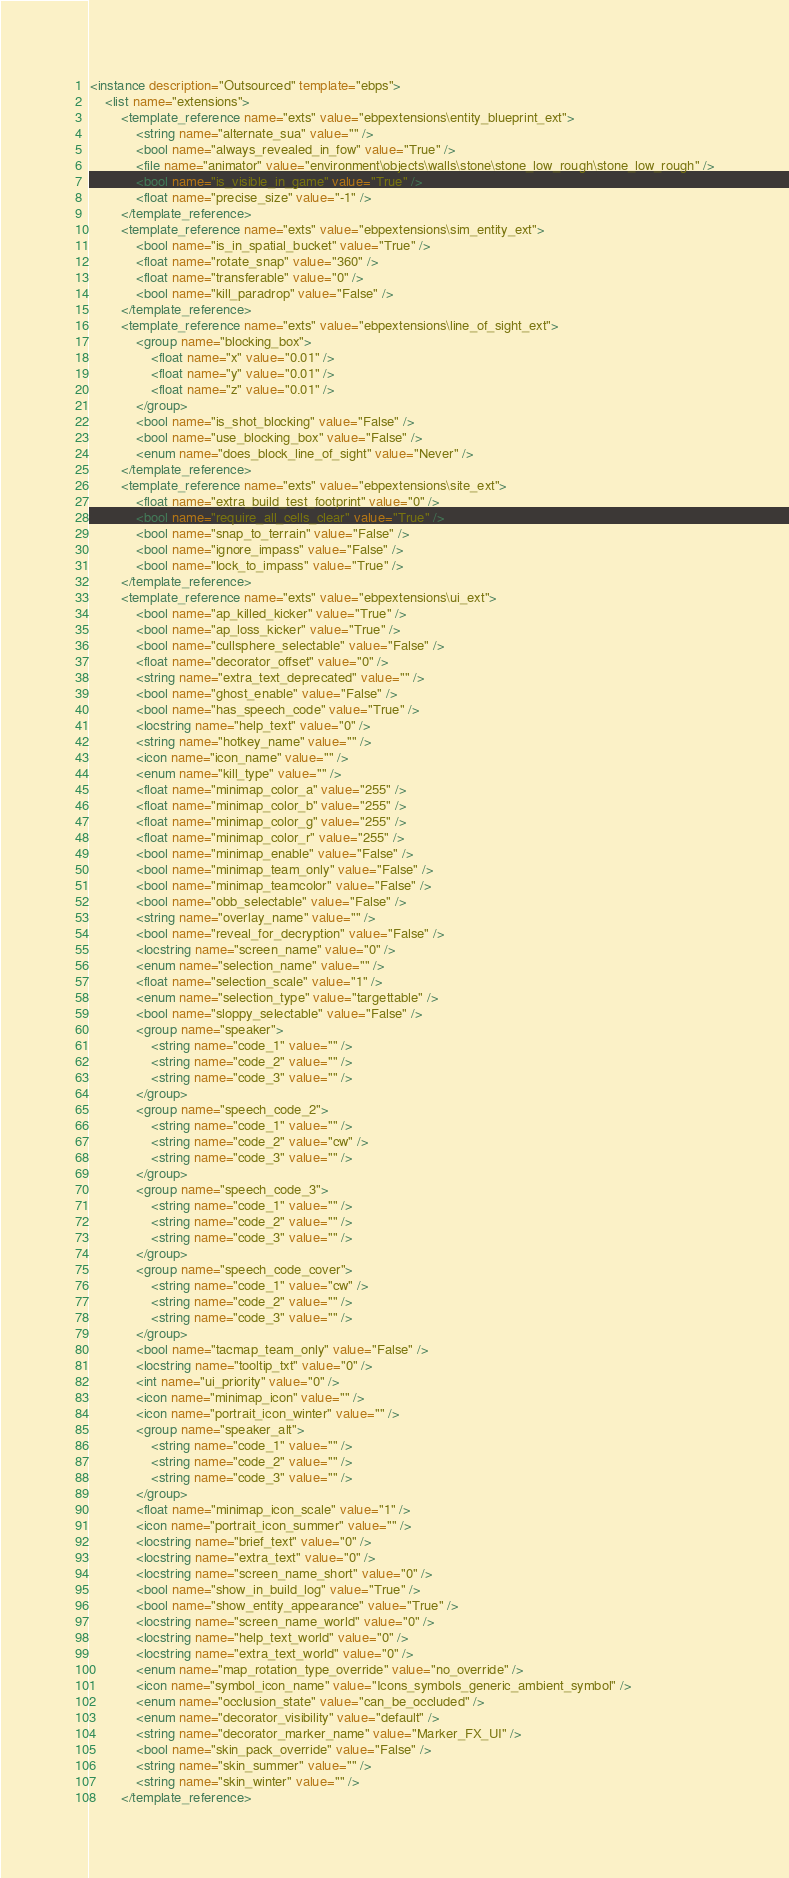Convert code to text. <code><loc_0><loc_0><loc_500><loc_500><_XML_><instance description="Outsourced" template="ebps">
	<list name="extensions">
		<template_reference name="exts" value="ebpextensions\entity_blueprint_ext">
			<string name="alternate_sua" value="" />
			<bool name="always_revealed_in_fow" value="True" />
			<file name="animator" value="environment\objects\walls\stone\stone_low_rough\stone_low_rough" />
			<bool name="is_visible_in_game" value="True" />
			<float name="precise_size" value="-1" />
		</template_reference>
		<template_reference name="exts" value="ebpextensions\sim_entity_ext">
			<bool name="is_in_spatial_bucket" value="True" />
			<float name="rotate_snap" value="360" />
			<float name="transferable" value="0" />
			<bool name="kill_paradrop" value="False" />
		</template_reference>
		<template_reference name="exts" value="ebpextensions\line_of_sight_ext">
			<group name="blocking_box">
				<float name="x" value="0.01" />
				<float name="y" value="0.01" />
				<float name="z" value="0.01" />
			</group>
			<bool name="is_shot_blocking" value="False" />
			<bool name="use_blocking_box" value="False" />
			<enum name="does_block_line_of_sight" value="Never" />
		</template_reference>
		<template_reference name="exts" value="ebpextensions\site_ext">
			<float name="extra_build_test_footprint" value="0" />
			<bool name="require_all_cells_clear" value="True" />
			<bool name="snap_to_terrain" value="False" />
			<bool name="ignore_impass" value="False" />
			<bool name="lock_to_impass" value="True" />
		</template_reference>
		<template_reference name="exts" value="ebpextensions\ui_ext">
			<bool name="ap_killed_kicker" value="True" />
			<bool name="ap_loss_kicker" value="True" />
			<bool name="cullsphere_selectable" value="False" />
			<float name="decorator_offset" value="0" />
			<string name="extra_text_deprecated" value="" />
			<bool name="ghost_enable" value="False" />
			<bool name="has_speech_code" value="True" />
			<locstring name="help_text" value="0" />
			<string name="hotkey_name" value="" />
			<icon name="icon_name" value="" />
			<enum name="kill_type" value="" />
			<float name="minimap_color_a" value="255" />
			<float name="minimap_color_b" value="255" />
			<float name="minimap_color_g" value="255" />
			<float name="minimap_color_r" value="255" />
			<bool name="minimap_enable" value="False" />
			<bool name="minimap_team_only" value="False" />
			<bool name="minimap_teamcolor" value="False" />
			<bool name="obb_selectable" value="False" />
			<string name="overlay_name" value="" />
			<bool name="reveal_for_decryption" value="False" />
			<locstring name="screen_name" value="0" />
			<enum name="selection_name" value="" />
			<float name="selection_scale" value="1" />
			<enum name="selection_type" value="targettable" />
			<bool name="sloppy_selectable" value="False" />
			<group name="speaker">
				<string name="code_1" value="" />
				<string name="code_2" value="" />
				<string name="code_3" value="" />
			</group>
			<group name="speech_code_2">
				<string name="code_1" value="" />
				<string name="code_2" value="cw" />
				<string name="code_3" value="" />
			</group>
			<group name="speech_code_3">
				<string name="code_1" value="" />
				<string name="code_2" value="" />
				<string name="code_3" value="" />
			</group>
			<group name="speech_code_cover">
				<string name="code_1" value="cw" />
				<string name="code_2" value="" />
				<string name="code_3" value="" />
			</group>
			<bool name="tacmap_team_only" value="False" />
			<locstring name="tooltip_txt" value="0" />
			<int name="ui_priority" value="0" />
			<icon name="minimap_icon" value="" />
			<icon name="portrait_icon_winter" value="" />
			<group name="speaker_alt">
				<string name="code_1" value="" />
				<string name="code_2" value="" />
				<string name="code_3" value="" />
			</group>
			<float name="minimap_icon_scale" value="1" />
			<icon name="portrait_icon_summer" value="" />
			<locstring name="brief_text" value="0" />
			<locstring name="extra_text" value="0" />
			<locstring name="screen_name_short" value="0" />
			<bool name="show_in_build_log" value="True" />
			<bool name="show_entity_appearance" value="True" />
			<locstring name="screen_name_world" value="0" />
			<locstring name="help_text_world" value="0" />
			<locstring name="extra_text_world" value="0" />
			<enum name="map_rotation_type_override" value="no_override" />
			<icon name="symbol_icon_name" value="Icons_symbols_generic_ambient_symbol" />
			<enum name="occlusion_state" value="can_be_occluded" />
			<enum name="decorator_visibility" value="default" />
			<string name="decorator_marker_name" value="Marker_FX_UI" />
			<bool name="skin_pack_override" value="False" />
			<string name="skin_summer" value="" />
			<string name="skin_winter" value="" />
		</template_reference></code> 